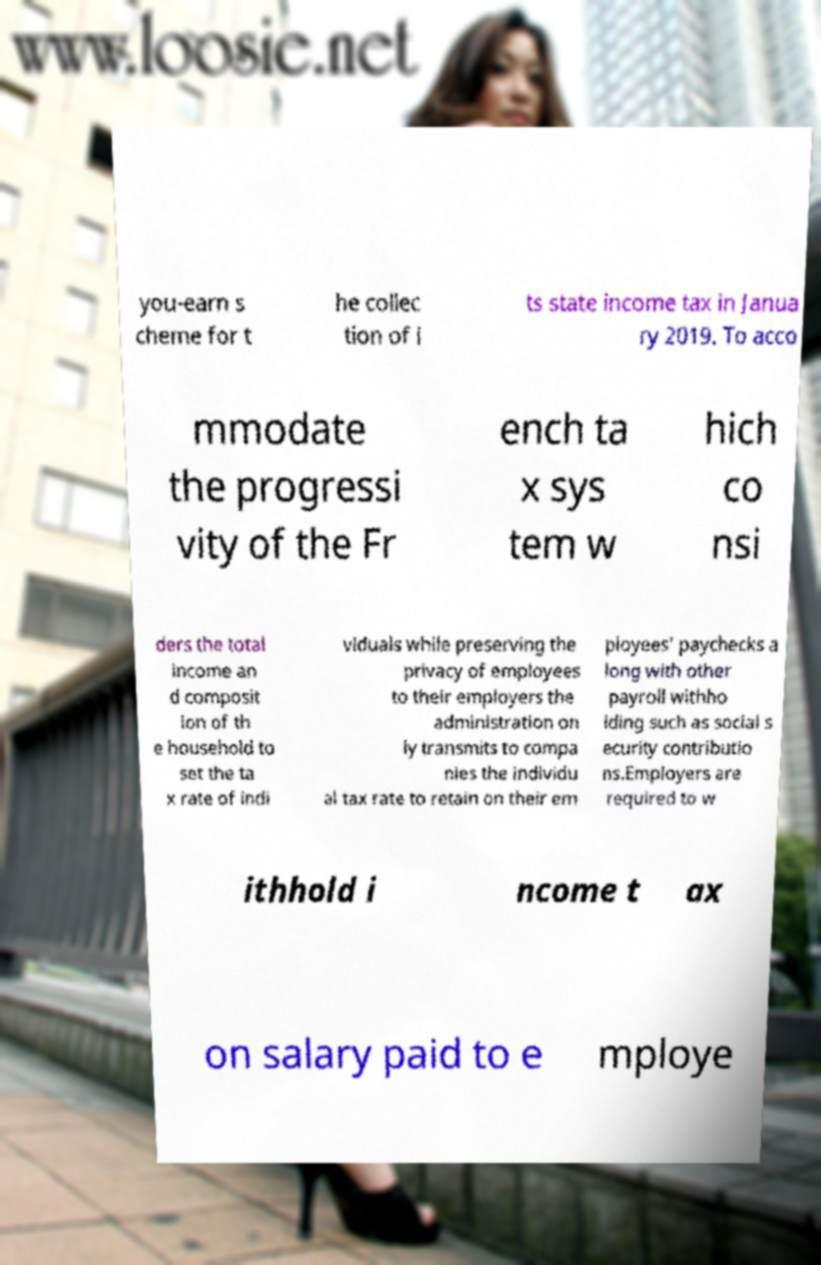Could you assist in decoding the text presented in this image and type it out clearly? you-earn s cheme for t he collec tion of i ts state income tax in Janua ry 2019. To acco mmodate the progressi vity of the Fr ench ta x sys tem w hich co nsi ders the total income an d composit ion of th e household to set the ta x rate of indi viduals while preserving the privacy of employees to their employers the administration on ly transmits to compa nies the individu al tax rate to retain on their em ployees' paychecks a long with other payroll withho lding such as social s ecurity contributio ns.Employers are required to w ithhold i ncome t ax on salary paid to e mploye 